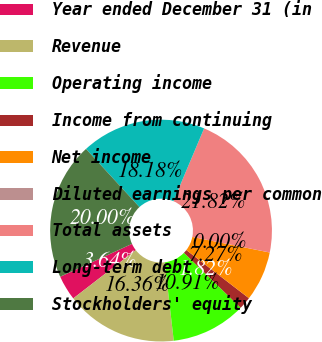Convert chart. <chart><loc_0><loc_0><loc_500><loc_500><pie_chart><fcel>Year ended December 31 (in<fcel>Revenue<fcel>Operating income<fcel>Income from continuing<fcel>Net income<fcel>Diluted earnings per common<fcel>Total assets<fcel>Long-term debt<fcel>Stockholders' equity<nl><fcel>3.64%<fcel>16.36%<fcel>10.91%<fcel>1.82%<fcel>7.27%<fcel>0.0%<fcel>21.82%<fcel>18.18%<fcel>20.0%<nl></chart> 